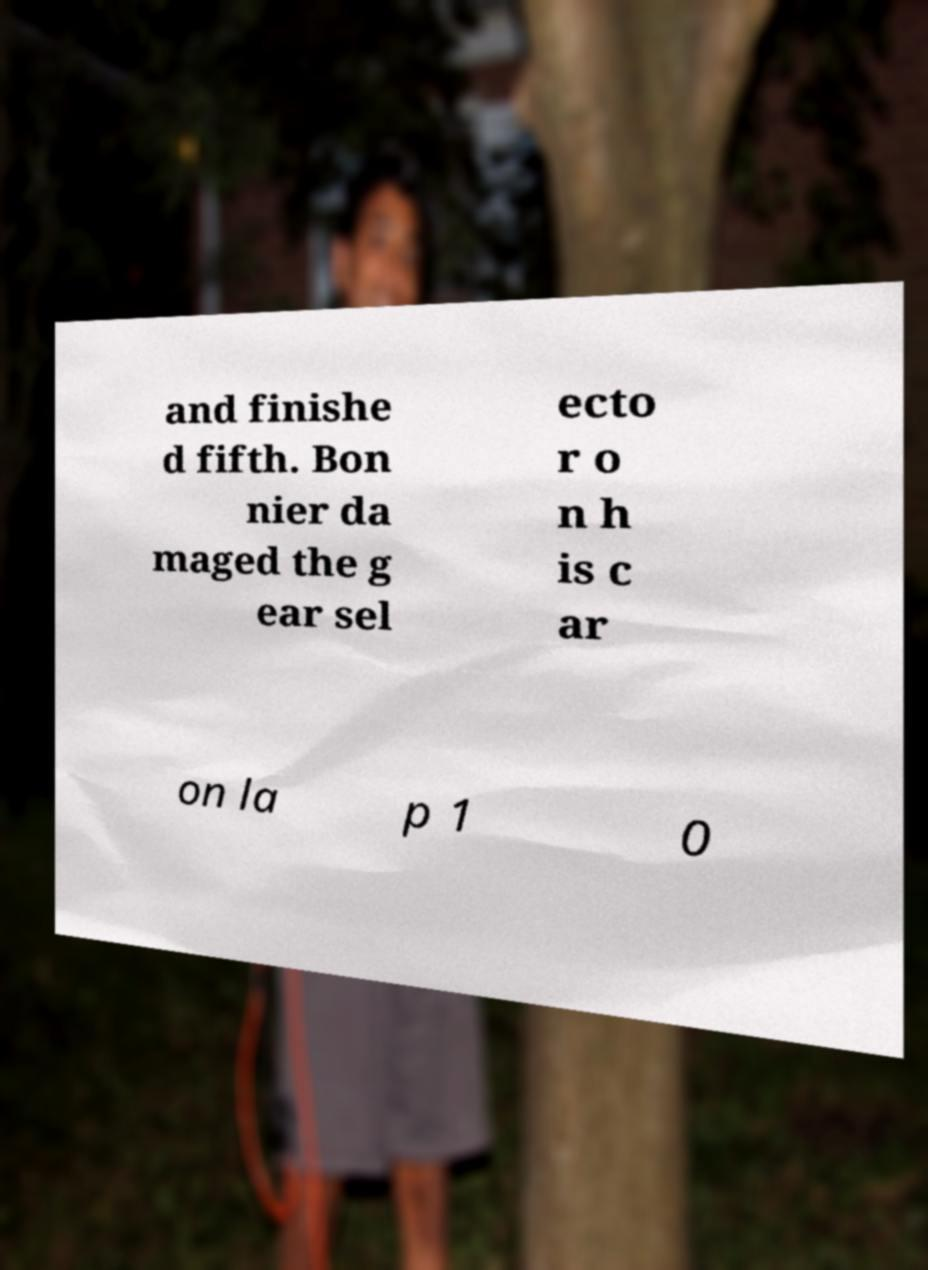Can you read and provide the text displayed in the image?This photo seems to have some interesting text. Can you extract and type it out for me? and finishe d fifth. Bon nier da maged the g ear sel ecto r o n h is c ar on la p 1 0 